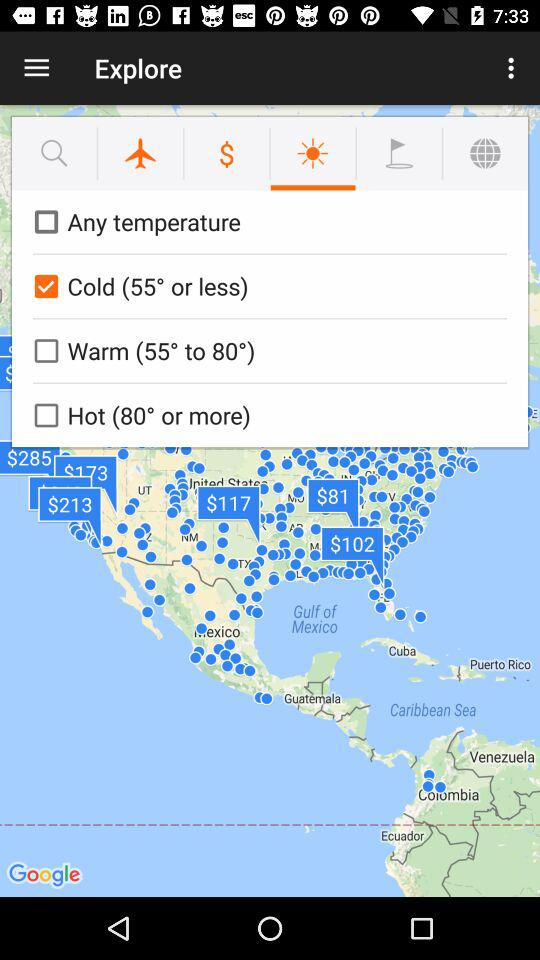What is the current status of "Warm (55° to 80°)"? The current status of "Warm (55° to 80°)" is "off". 